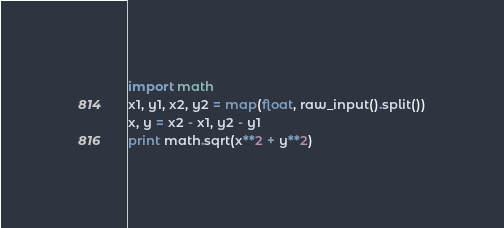<code> <loc_0><loc_0><loc_500><loc_500><_Python_>import math
x1, y1, x2, y2 = map(float, raw_input().split())
x, y = x2 - x1, y2 - y1
print math.sqrt(x**2 + y**2)</code> 